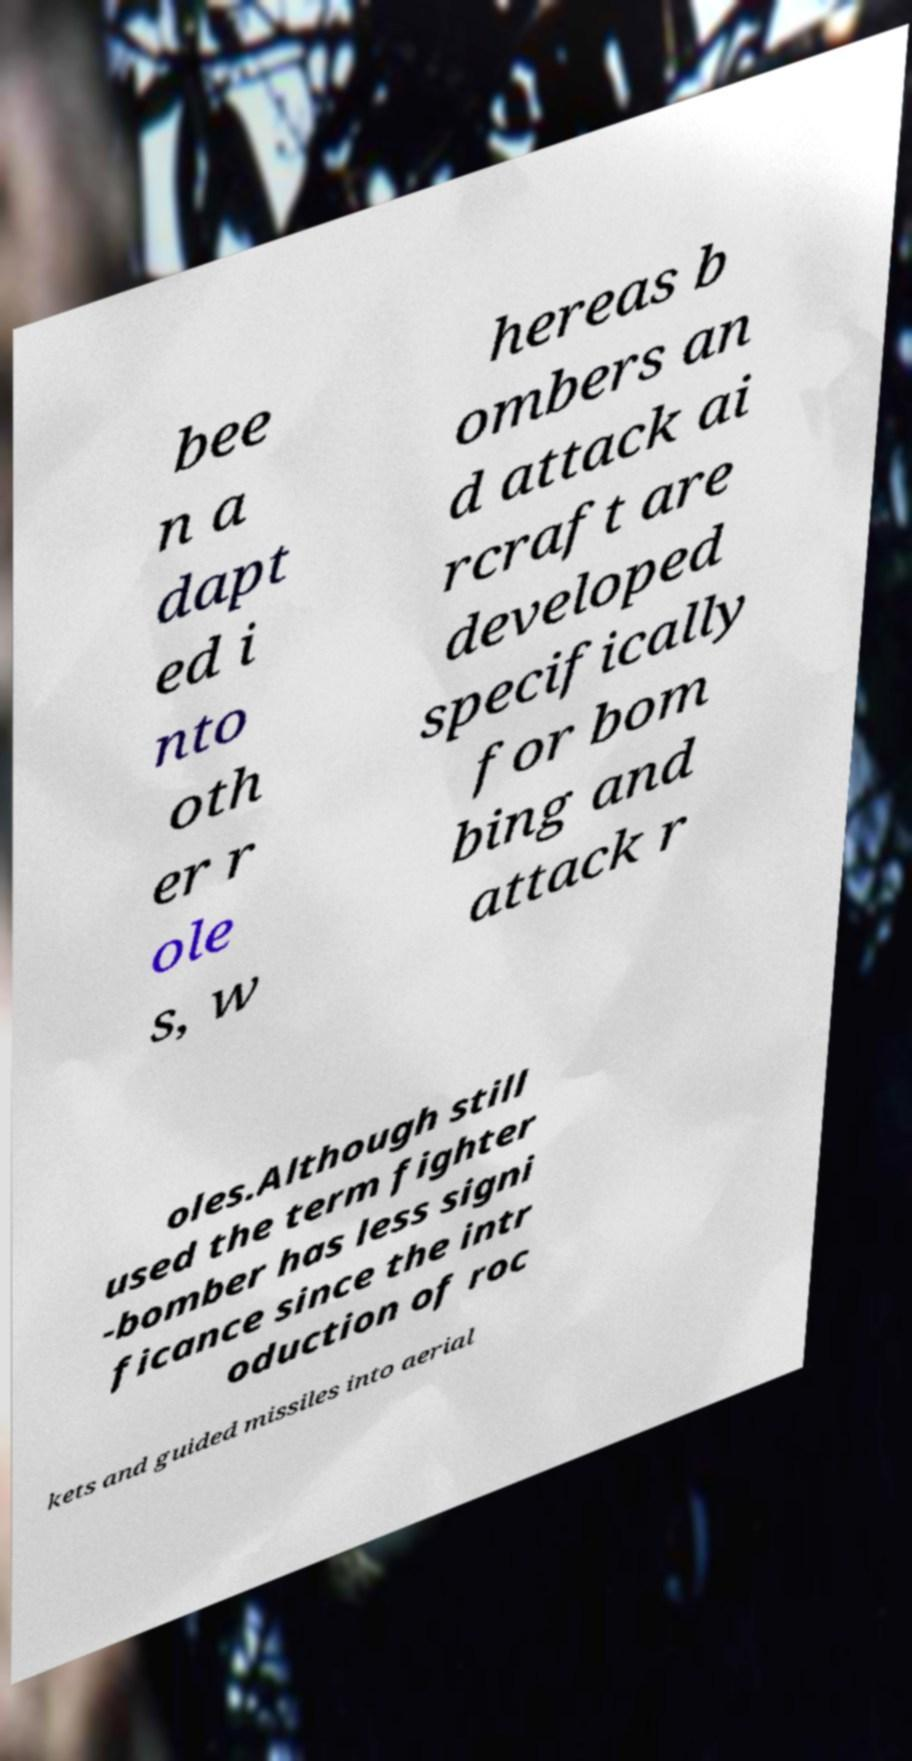Can you read and provide the text displayed in the image?This photo seems to have some interesting text. Can you extract and type it out for me? bee n a dapt ed i nto oth er r ole s, w hereas b ombers an d attack ai rcraft are developed specifically for bom bing and attack r oles.Although still used the term fighter -bomber has less signi ficance since the intr oduction of roc kets and guided missiles into aerial 